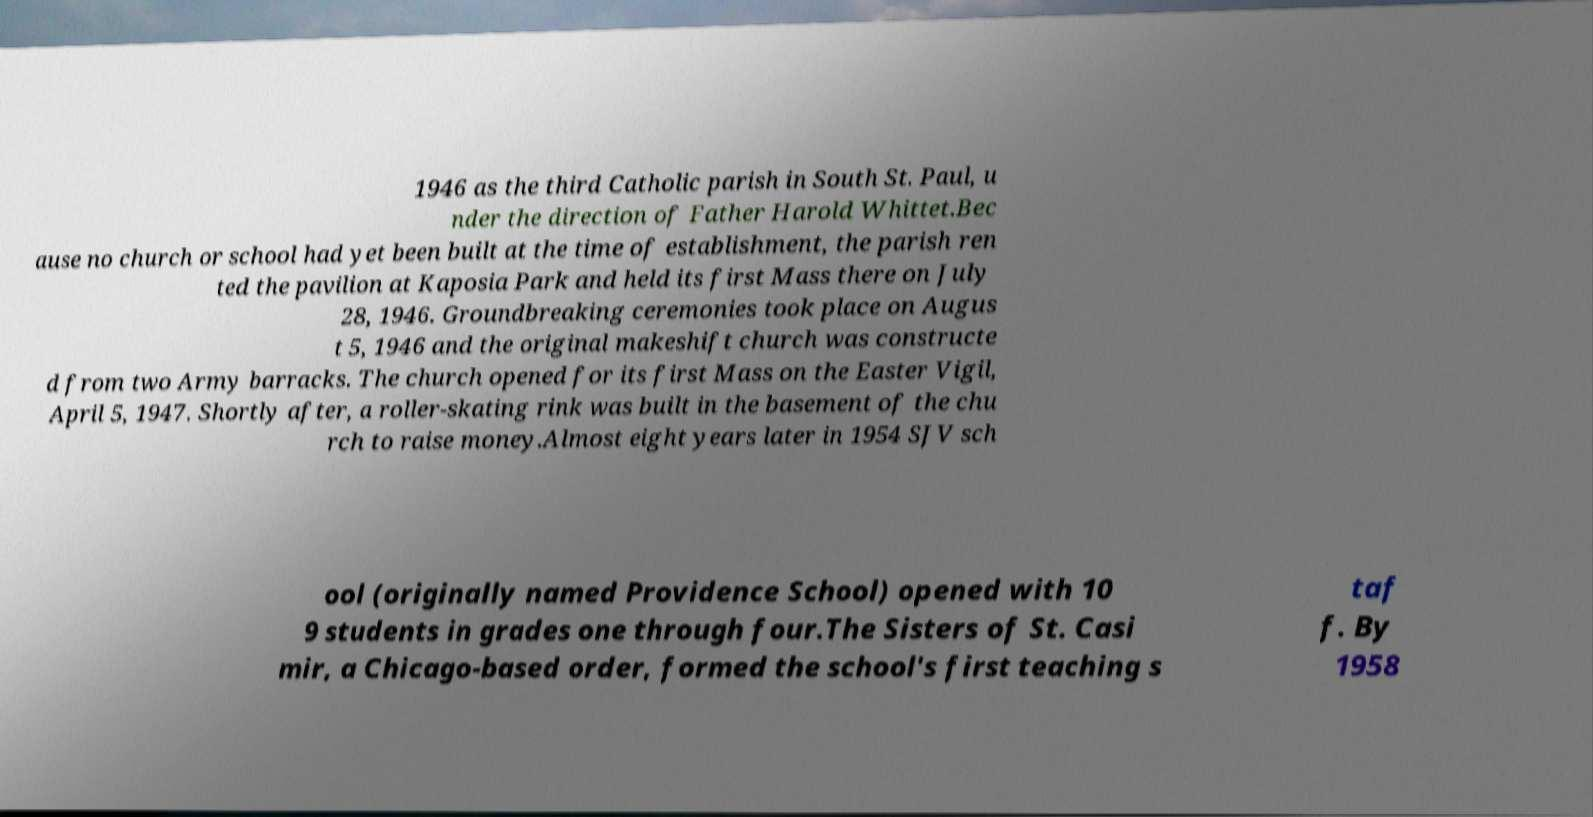Can you read and provide the text displayed in the image?This photo seems to have some interesting text. Can you extract and type it out for me? 1946 as the third Catholic parish in South St. Paul, u nder the direction of Father Harold Whittet.Bec ause no church or school had yet been built at the time of establishment, the parish ren ted the pavilion at Kaposia Park and held its first Mass there on July 28, 1946. Groundbreaking ceremonies took place on Augus t 5, 1946 and the original makeshift church was constructe d from two Army barracks. The church opened for its first Mass on the Easter Vigil, April 5, 1947. Shortly after, a roller-skating rink was built in the basement of the chu rch to raise money.Almost eight years later in 1954 SJV sch ool (originally named Providence School) opened with 10 9 students in grades one through four.The Sisters of St. Casi mir, a Chicago-based order, formed the school's first teaching s taf f. By 1958 